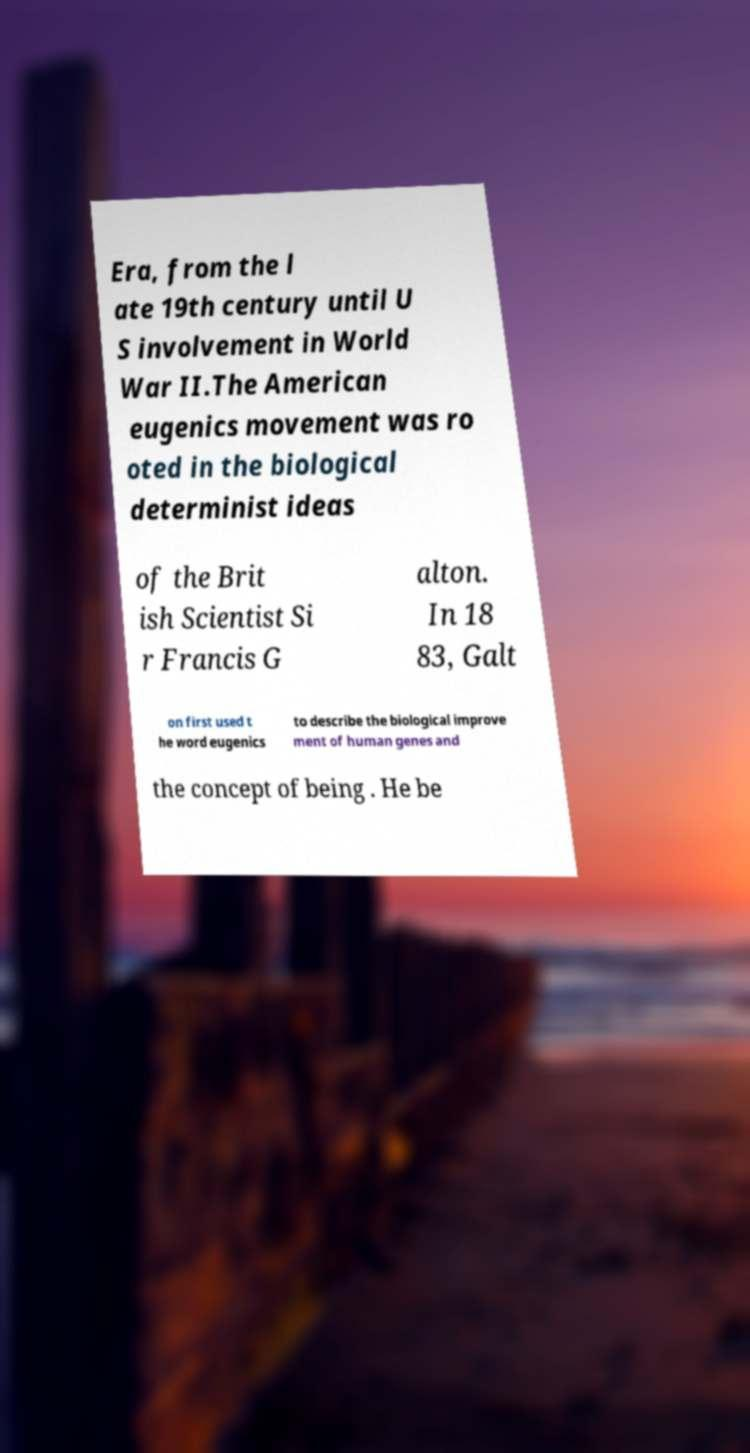Please read and relay the text visible in this image. What does it say? Era, from the l ate 19th century until U S involvement in World War II.The American eugenics movement was ro oted in the biological determinist ideas of the Brit ish Scientist Si r Francis G alton. In 18 83, Galt on first used t he word eugenics to describe the biological improve ment of human genes and the concept of being . He be 